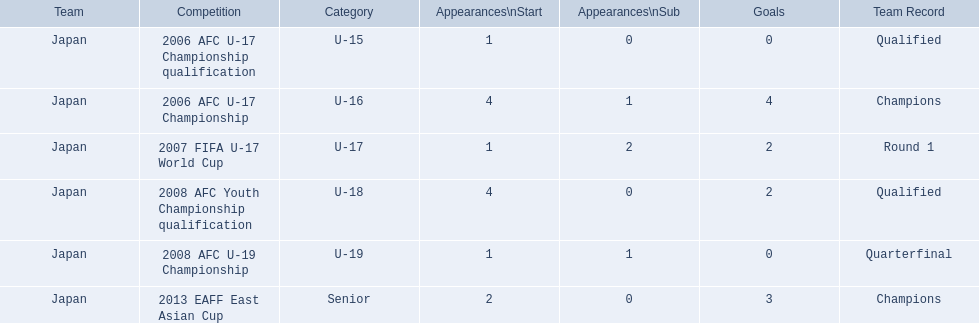What was the squad's record in 2006? Round 1. To which event did this relate? 2006 AFC U-17 Championship. 